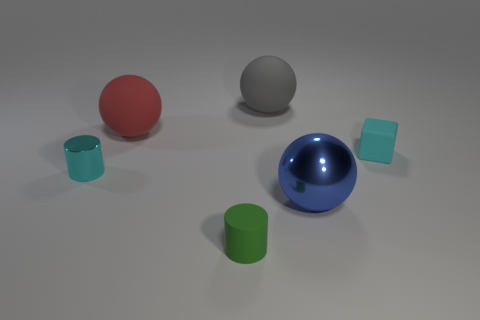Are there any other things that have the same shape as the big gray thing? Yes, the big gray sphere shares its shape with the smaller blue sphere in the image. Both objects are spherical, which means they are perfectly round in every direction. 